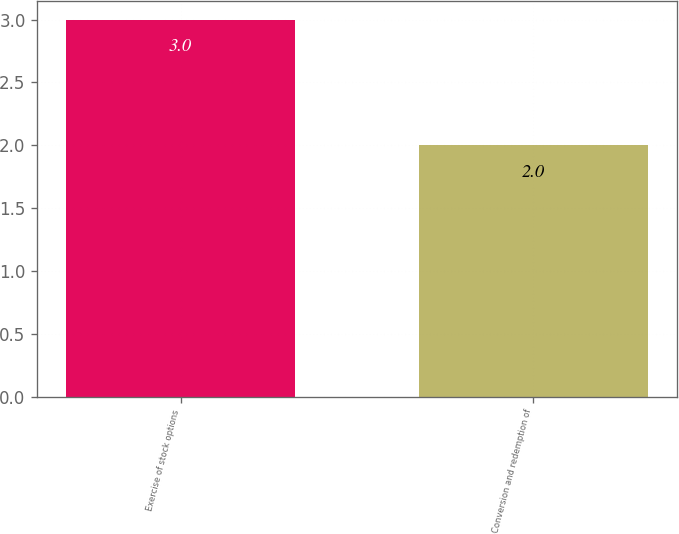Convert chart. <chart><loc_0><loc_0><loc_500><loc_500><bar_chart><fcel>Exercise of stock options<fcel>Conversion and redemption of<nl><fcel>3<fcel>2<nl></chart> 